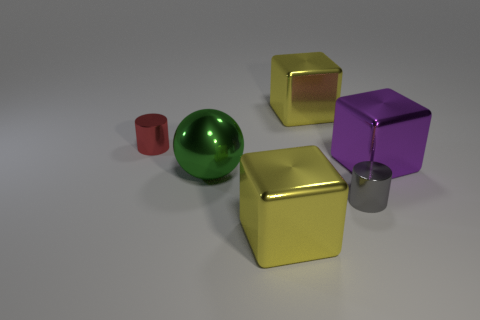Which object in the image reflects light the most? The green sphere reflects light the most, giving it a shiny appearance. 